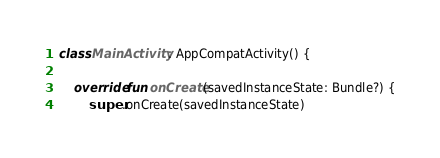Convert code to text. <code><loc_0><loc_0><loc_500><loc_500><_Kotlin_>class MainActivity : AppCompatActivity() {

    override fun onCreate(savedInstanceState: Bundle?) {
        super.onCreate(savedInstanceState)</code> 